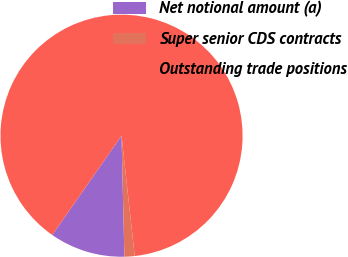Convert chart. <chart><loc_0><loc_0><loc_500><loc_500><pie_chart><fcel>Net notional amount (a)<fcel>Super senior CDS contracts<fcel>Outstanding trade positions<nl><fcel>10.08%<fcel>1.36%<fcel>88.56%<nl></chart> 